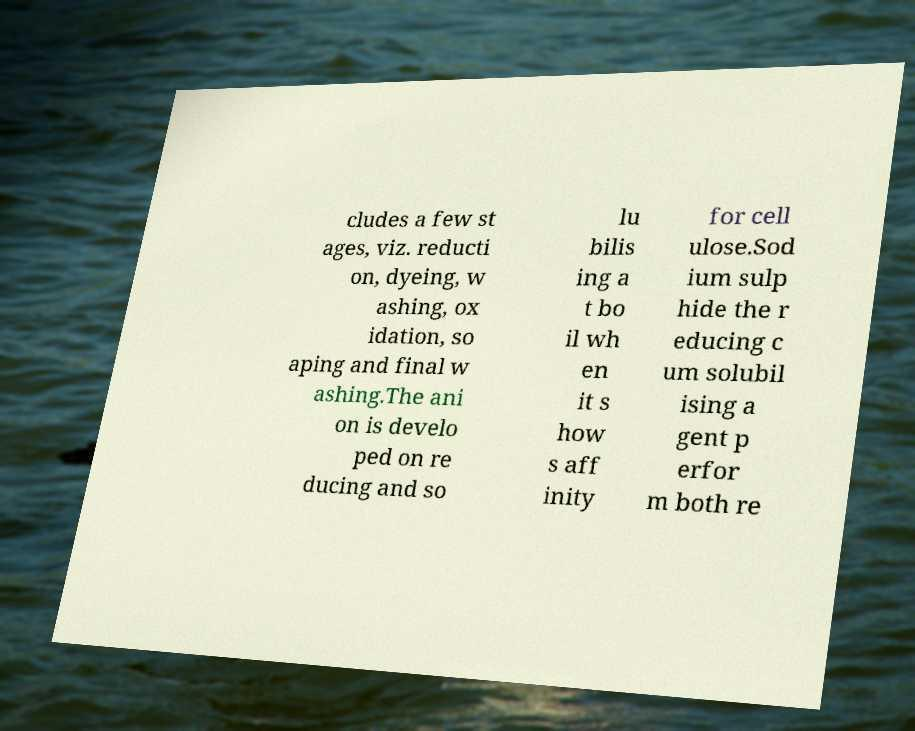There's text embedded in this image that I need extracted. Can you transcribe it verbatim? cludes a few st ages, viz. reducti on, dyeing, w ashing, ox idation, so aping and final w ashing.The ani on is develo ped on re ducing and so lu bilis ing a t bo il wh en it s how s aff inity for cell ulose.Sod ium sulp hide the r educing c um solubil ising a gent p erfor m both re 